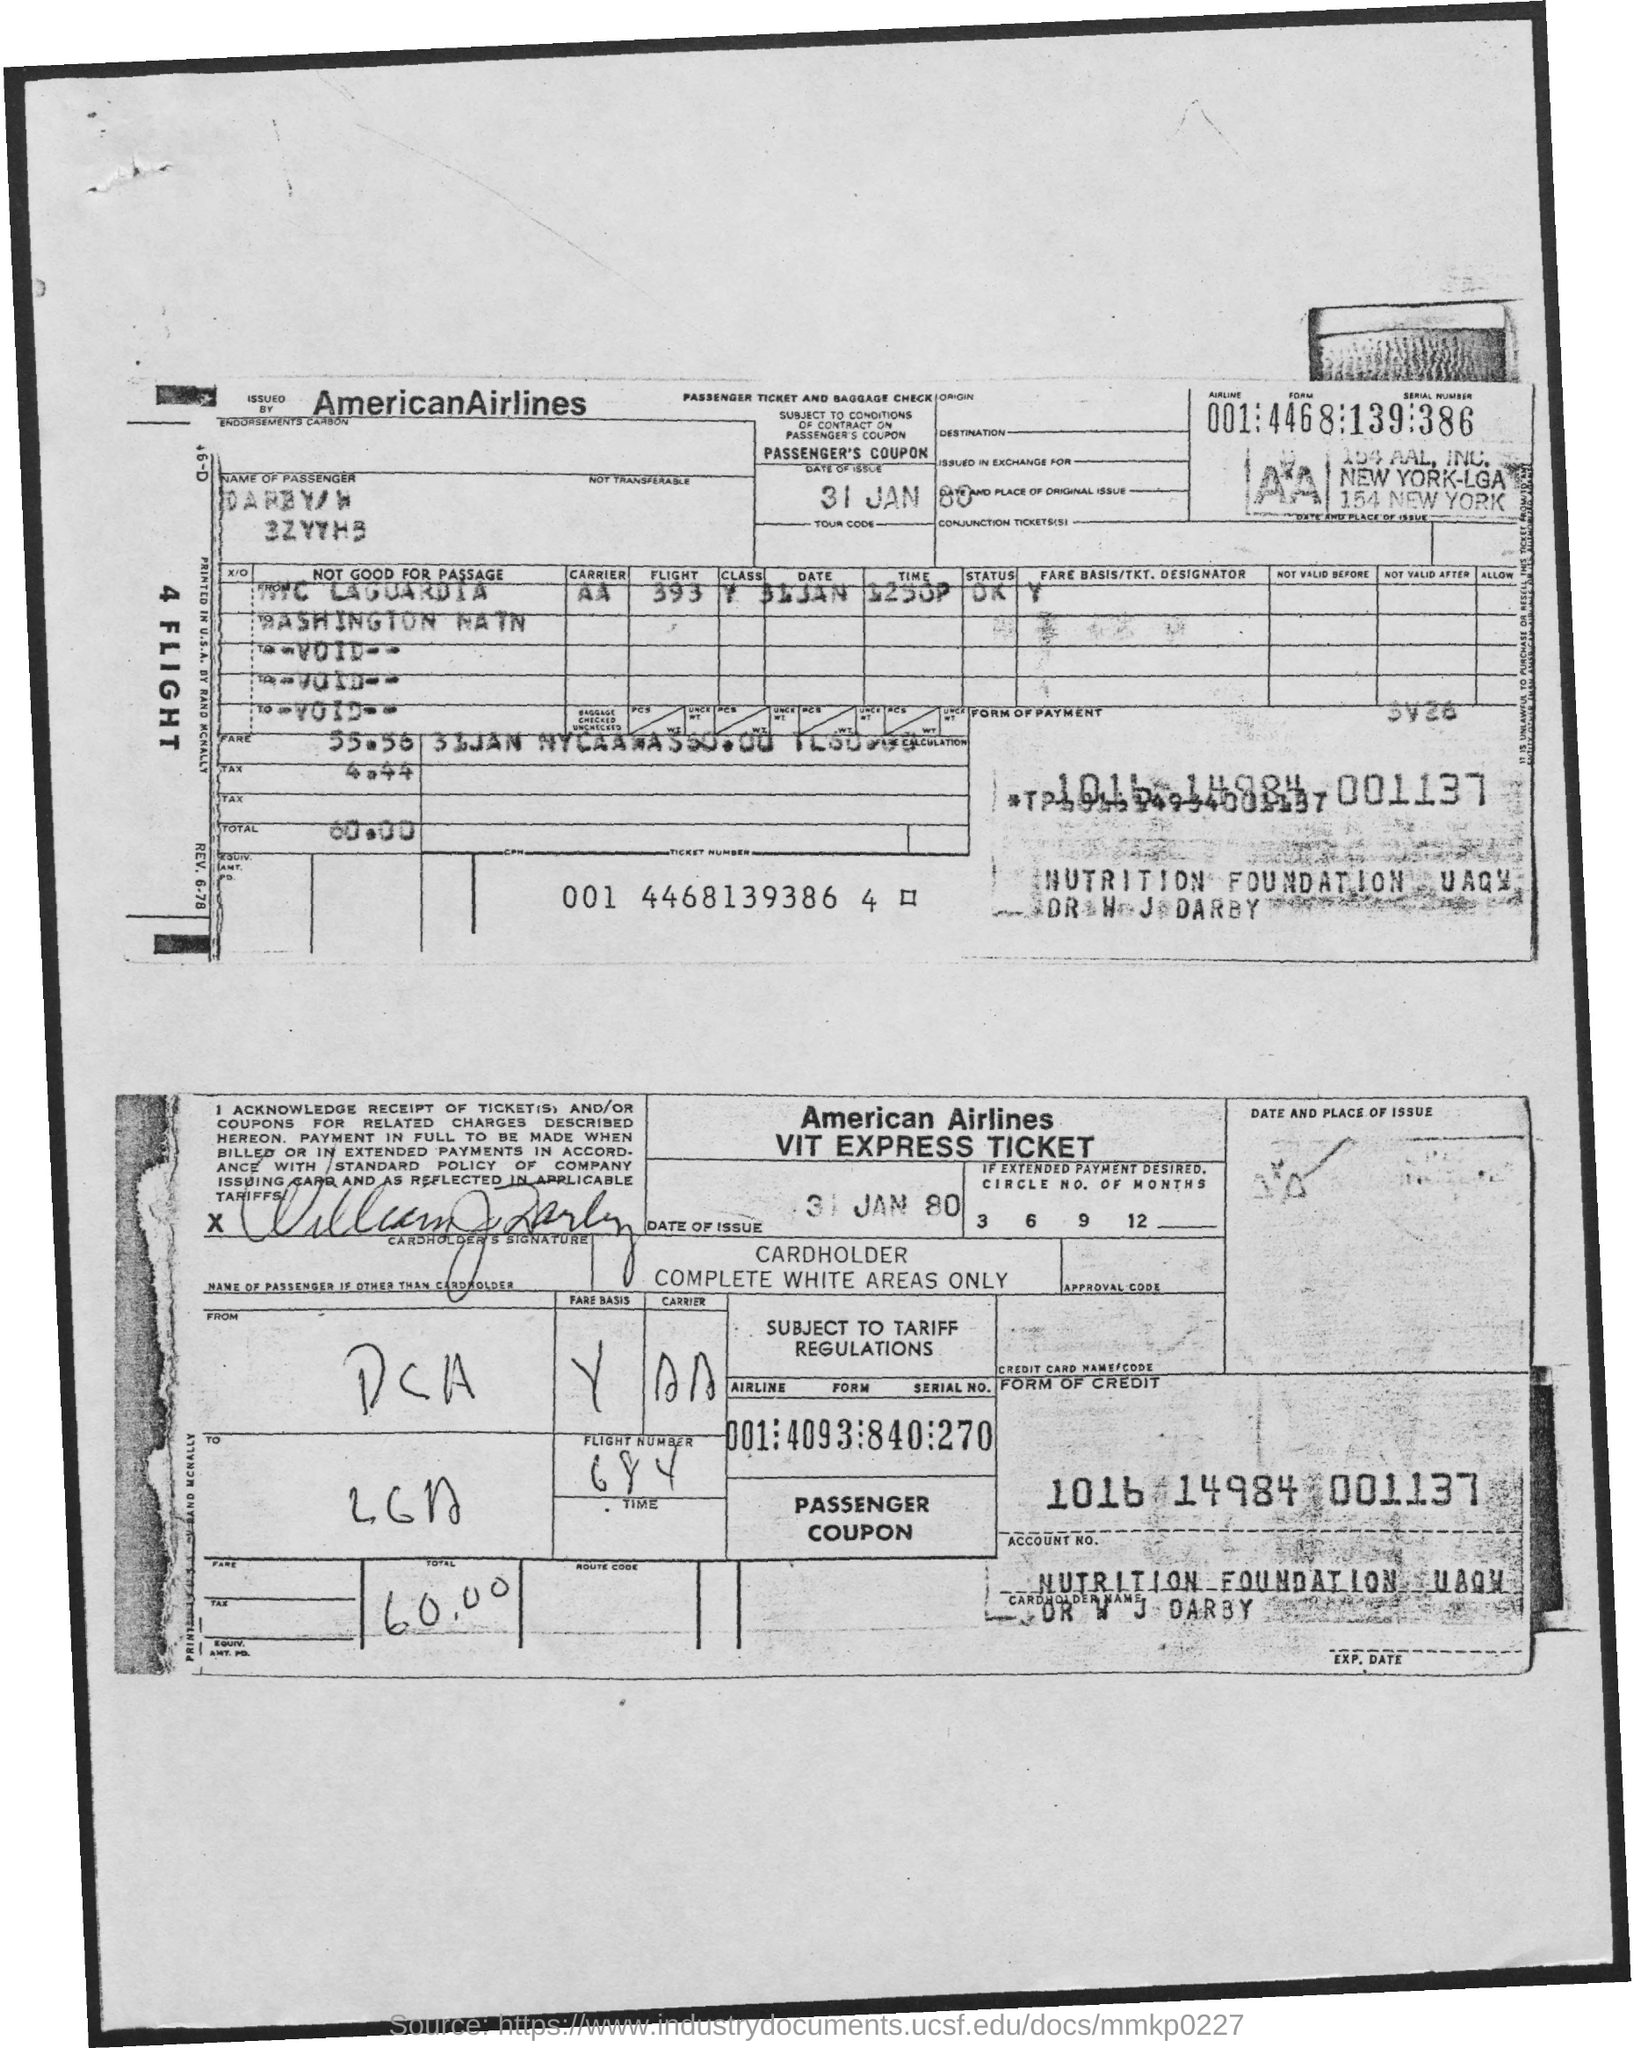What is the date of the issue?
Provide a short and direct response. 31 jan 80. What is the name of the Airline?
Ensure brevity in your answer.  AMERICAN AIRLINES. What is the total amount?
Offer a very short reply. 60.00. What is the tax amount?
Your answer should be very brief. 4.44. What is the fare?
Your answer should be very brief. 55.56. What is the flight number?
Your answer should be compact. 684. 